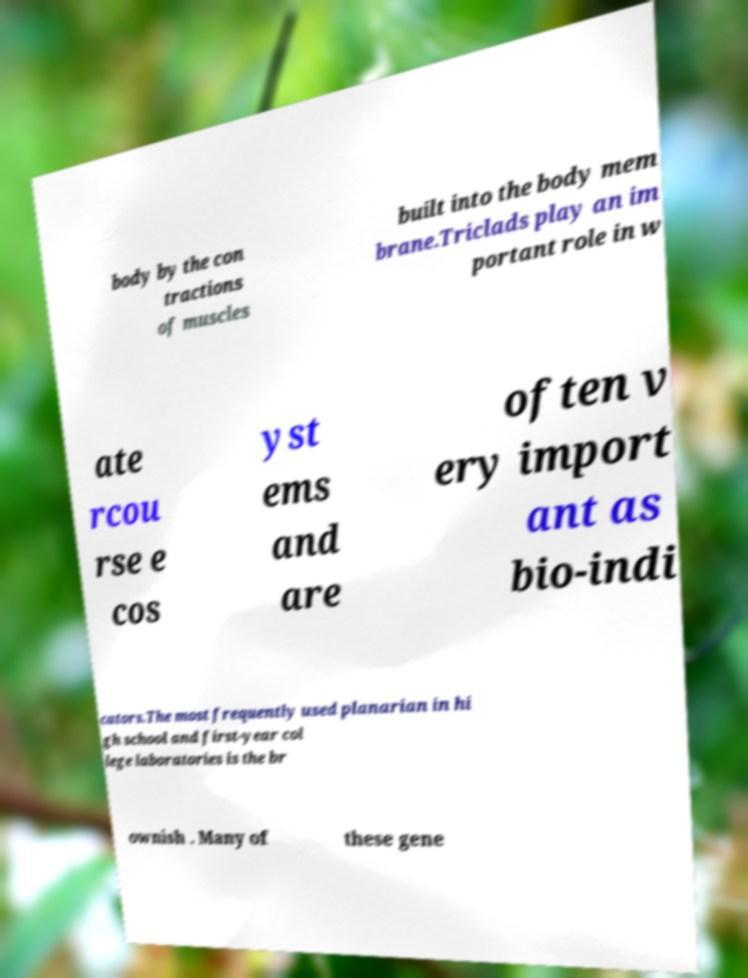Can you read and provide the text displayed in the image?This photo seems to have some interesting text. Can you extract and type it out for me? body by the con tractions of muscles built into the body mem brane.Triclads play an im portant role in w ate rcou rse e cos yst ems and are often v ery import ant as bio-indi cators.The most frequently used planarian in hi gh school and first-year col lege laboratories is the br ownish . Many of these gene 